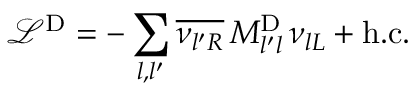<formula> <loc_0><loc_0><loc_500><loc_500>\mathcal { L } ^ { D } = - \sum _ { l , l ^ { \prime } } \overline { { { \nu _ { { l ^ { \prime } } R } } } } \, M _ { l ^ { \prime } l } ^ { D } \, \nu _ { { l } L } + h . c . \,</formula> 